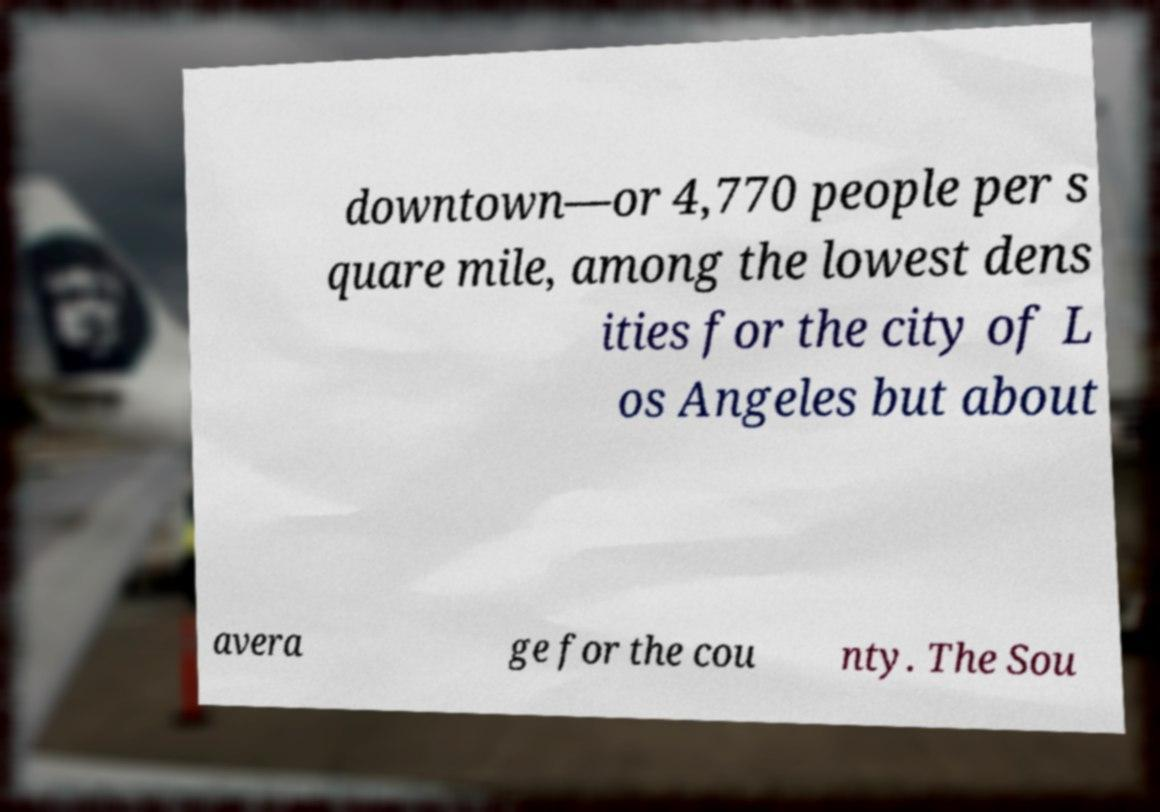There's text embedded in this image that I need extracted. Can you transcribe it verbatim? downtown—or 4,770 people per s quare mile, among the lowest dens ities for the city of L os Angeles but about avera ge for the cou nty. The Sou 